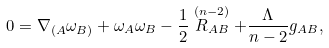Convert formula to latex. <formula><loc_0><loc_0><loc_500><loc_500>0 = \nabla _ { ( A } \omega _ { B ) } + \omega _ { A } \omega _ { B } - \frac { 1 } { 2 } \stackrel { ( n - 2 ) } { R _ { A B } } + \frac { \Lambda } { n - 2 } g _ { A B } ,</formula> 